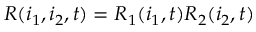<formula> <loc_0><loc_0><loc_500><loc_500>R ( i _ { 1 } , i _ { 2 } , t ) = R _ { 1 } ( i _ { 1 } , t ) R _ { 2 } ( i _ { 2 } , t )</formula> 